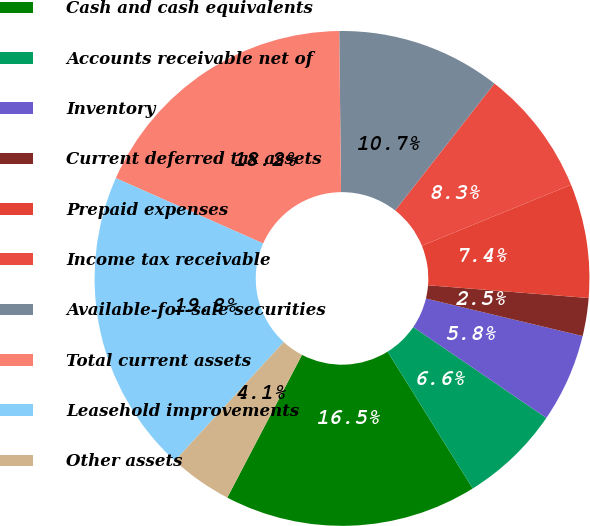Convert chart to OTSL. <chart><loc_0><loc_0><loc_500><loc_500><pie_chart><fcel>Cash and cash equivalents<fcel>Accounts receivable net of<fcel>Inventory<fcel>Current deferred tax assets<fcel>Prepaid expenses<fcel>Income tax receivable<fcel>Available-for-sale securities<fcel>Total current assets<fcel>Leasehold improvements<fcel>Other assets<nl><fcel>16.53%<fcel>6.61%<fcel>5.79%<fcel>2.48%<fcel>7.44%<fcel>8.26%<fcel>10.74%<fcel>18.18%<fcel>19.83%<fcel>4.13%<nl></chart> 